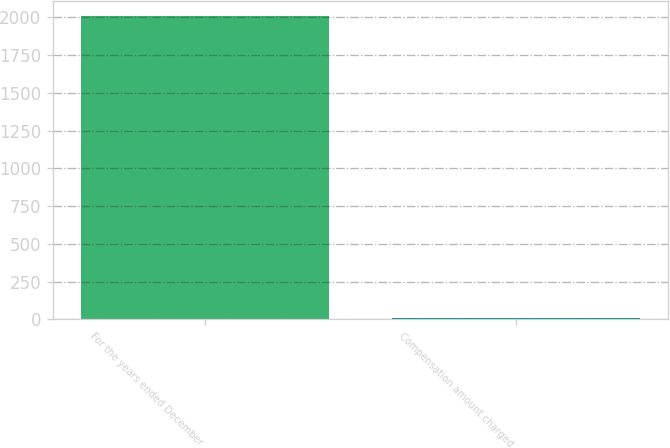Convert chart. <chart><loc_0><loc_0><loc_500><loc_500><bar_chart><fcel>For the years ended December<fcel>Compensation amount charged<nl><fcel>2008<fcel>9.1<nl></chart> 